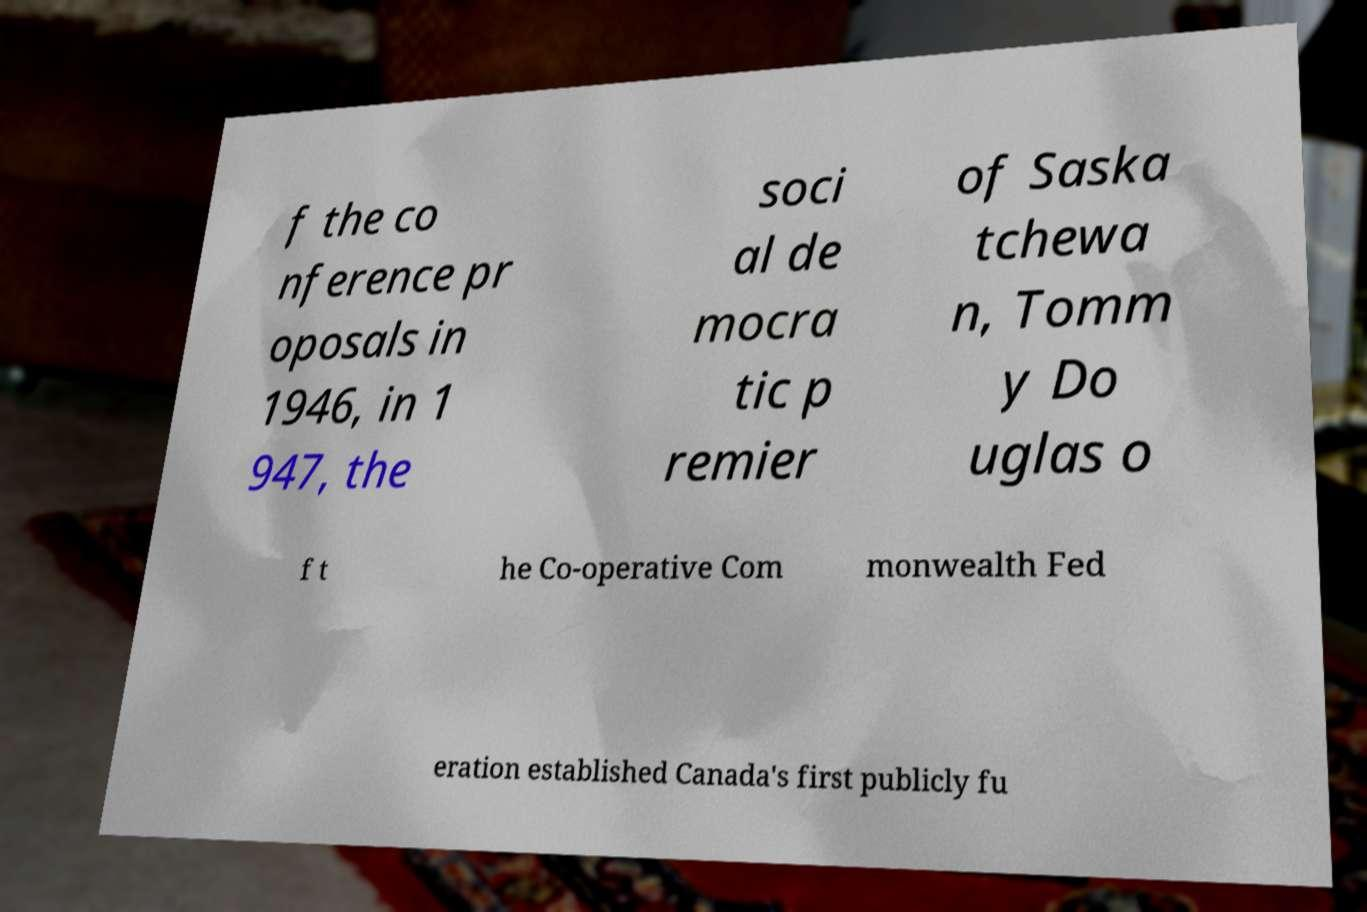What messages or text are displayed in this image? I need them in a readable, typed format. f the co nference pr oposals in 1946, in 1 947, the soci al de mocra tic p remier of Saska tchewa n, Tomm y Do uglas o f t he Co-operative Com monwealth Fed eration established Canada's first publicly fu 